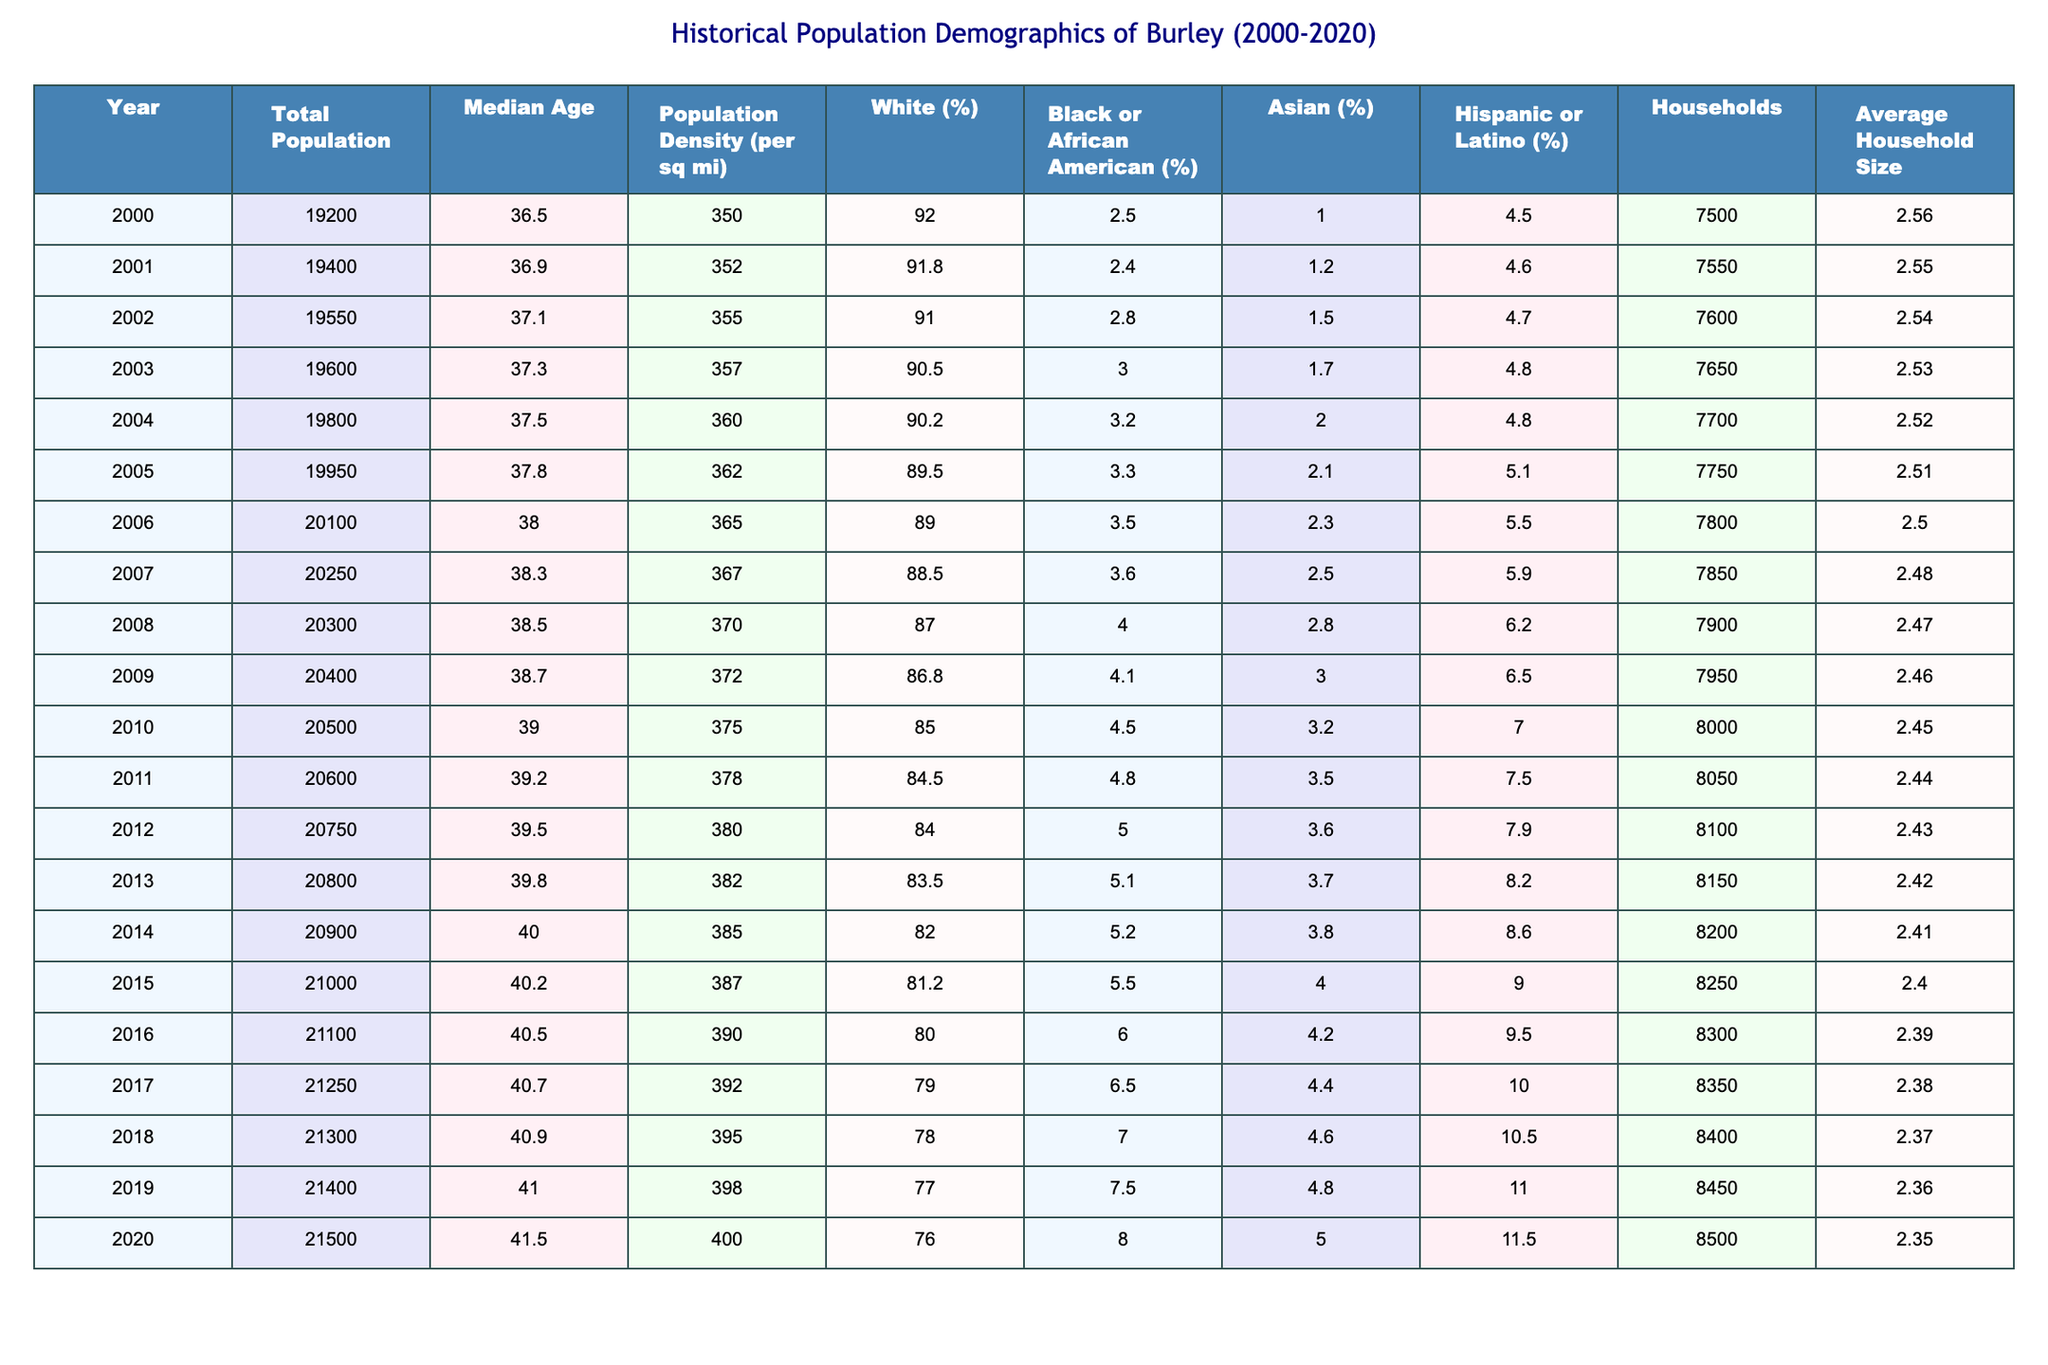What was the total population of Burley in 2010? In the table, the total population for the year 2010 is listed directly. It shows a total population of 20500.
Answer: 20500 What was the median age of the population in 2015? The table specifies the median age for the year 2015, which is 40.2.
Answer: 40.2 Which year had the highest population density, and what was that value? The highest population density value can be determined by scanning through the table. The year with the highest density is 2020, with a value of 400.
Answer: 2020, 400 Was the population of Burley greater in 2018 than in 2015? To answer this, we can compare the total population values of 2018 (21300) and 2015 (21000) in the table. Since 21300 is greater than 21000, the statement is true.
Answer: Yes What is the percentage increase of the White population from 2000 to 2020? The percentage of the White population in 2000 is 92.0 and in 2020 it is 76.0. The calculation for the percentage change is ((76.0 - 92.0)/92.0) * 100, which equals approximately -17.39%. This indicates a decline.
Answer: -17.39% What was the average household size in 2012, and how does it compare to the average household size in 2020? The average household size in 2012 is 2.43, while in 2020, it is 2.35. The comparison shows a decrease of 0.08 from 2012 to 2020.
Answer: 2.43, decreased Which racial demographic experienced the largest percentage increase from 2000 to 2020? To analyze the changes, we note the percentages for each group in 2000 and 2020. The Black or African American population grew from 2.5% to 8.0%. The increase can be calculated as (8.0 - 2.5) = 5.5 percentage points, making it the demographic with the largest increase.
Answer: Black or African American What was the average population increase per year from 2000 to 2020? To find this, we calculate the total increase in population from 19200 (2000) to 21500 (2020), which is 21500 - 19200 = 2300. We then divide this by the number of years, 20, resulting in an average increase of 115 per year.
Answer: 115 In which year did the number of households first exceed 8000? By examining the "Households" column, we see that the first year where households exceed 8000 is 2010, which has 8000 households.
Answer: 2010 Was the average household size decreasing over the years? A look at the average household size across the years shows a consistent decrease from 2.56 in 2000 to 2.35 in 2020, confirming the trend of decreasing size.
Answer: Yes 